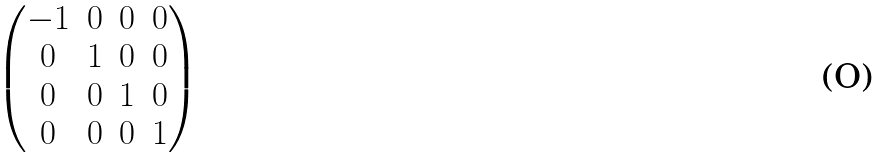<formula> <loc_0><loc_0><loc_500><loc_500>\begin{pmatrix} - 1 & 0 & 0 & 0 \\ 0 & 1 & 0 & 0 \\ 0 & 0 & 1 & 0 \\ 0 & 0 & 0 & 1 \end{pmatrix}</formula> 